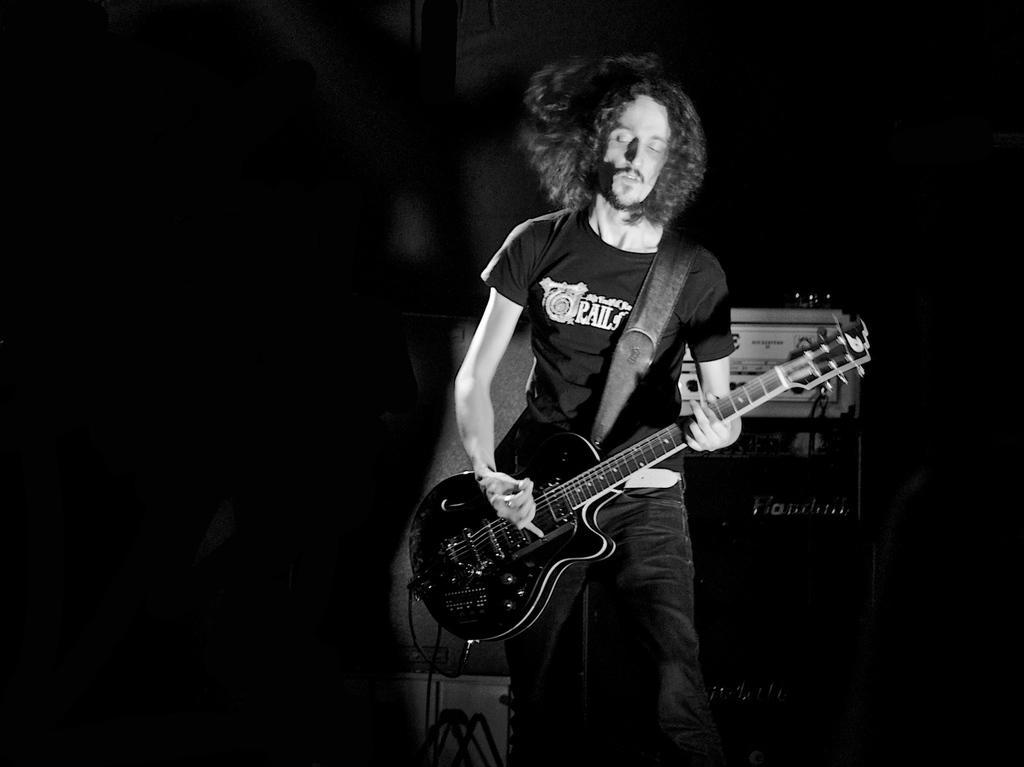Please provide a concise description of this image. In this picture a man is standing holding the guitar with his left hand and playing the guitar in the right hand. In the backdrop there is a equipment and some cables. 